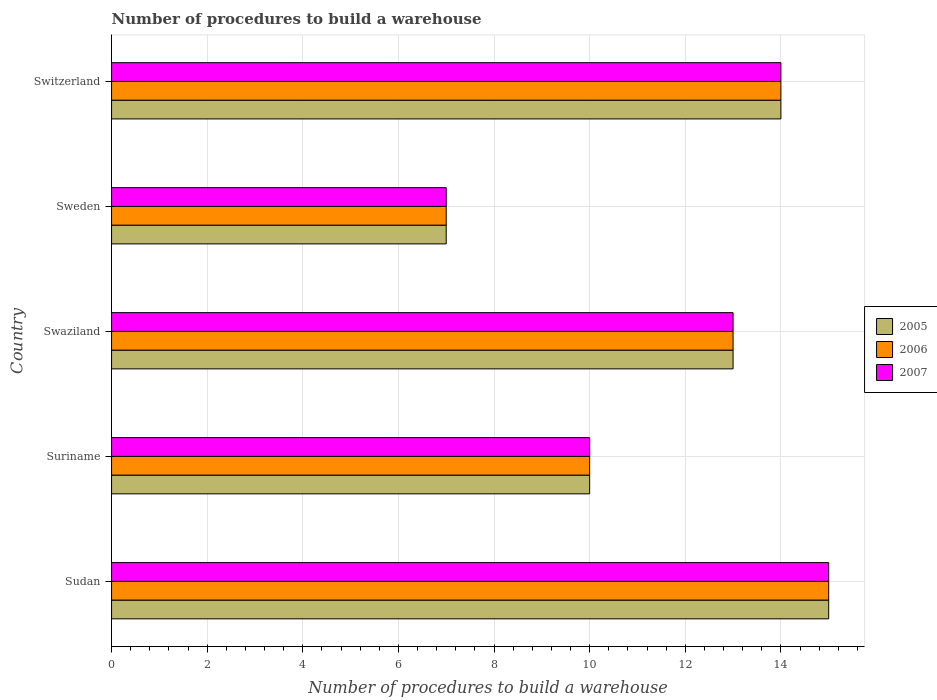How many different coloured bars are there?
Keep it short and to the point. 3. Are the number of bars on each tick of the Y-axis equal?
Offer a very short reply. Yes. How many bars are there on the 1st tick from the top?
Keep it short and to the point. 3. How many bars are there on the 1st tick from the bottom?
Your answer should be compact. 3. What is the label of the 5th group of bars from the top?
Your response must be concise. Sudan. In how many cases, is the number of bars for a given country not equal to the number of legend labels?
Offer a terse response. 0. Across all countries, what is the maximum number of procedures to build a warehouse in in 2005?
Provide a succinct answer. 15. In which country was the number of procedures to build a warehouse in in 2007 maximum?
Offer a very short reply. Sudan. In which country was the number of procedures to build a warehouse in in 2005 minimum?
Provide a short and direct response. Sweden. What is the difference between the number of procedures to build a warehouse in in 2006 in Sudan and the number of procedures to build a warehouse in in 2005 in Swaziland?
Give a very brief answer. 2. What is the difference between the number of procedures to build a warehouse in in 2006 and number of procedures to build a warehouse in in 2005 in Swaziland?
Your response must be concise. 0. What is the ratio of the number of procedures to build a warehouse in in 2007 in Suriname to that in Sweden?
Offer a terse response. 1.43. Is the difference between the number of procedures to build a warehouse in in 2006 in Sweden and Switzerland greater than the difference between the number of procedures to build a warehouse in in 2005 in Sweden and Switzerland?
Provide a short and direct response. No. What is the difference between the highest and the lowest number of procedures to build a warehouse in in 2005?
Offer a very short reply. 8. In how many countries, is the number of procedures to build a warehouse in in 2005 greater than the average number of procedures to build a warehouse in in 2005 taken over all countries?
Offer a terse response. 3. Is the sum of the number of procedures to build a warehouse in in 2005 in Sudan and Suriname greater than the maximum number of procedures to build a warehouse in in 2007 across all countries?
Make the answer very short. Yes. What does the 1st bar from the top in Swaziland represents?
Provide a succinct answer. 2007. What does the 2nd bar from the bottom in Suriname represents?
Your response must be concise. 2006. Are all the bars in the graph horizontal?
Ensure brevity in your answer.  Yes. How many countries are there in the graph?
Provide a succinct answer. 5. Are the values on the major ticks of X-axis written in scientific E-notation?
Provide a succinct answer. No. Does the graph contain grids?
Provide a short and direct response. Yes. How many legend labels are there?
Your answer should be compact. 3. How are the legend labels stacked?
Ensure brevity in your answer.  Vertical. What is the title of the graph?
Offer a terse response. Number of procedures to build a warehouse. Does "1991" appear as one of the legend labels in the graph?
Ensure brevity in your answer.  No. What is the label or title of the X-axis?
Keep it short and to the point. Number of procedures to build a warehouse. What is the label or title of the Y-axis?
Give a very brief answer. Country. What is the Number of procedures to build a warehouse of 2006 in Sudan?
Provide a succinct answer. 15. What is the Number of procedures to build a warehouse of 2007 in Suriname?
Provide a short and direct response. 10. What is the Number of procedures to build a warehouse of 2005 in Swaziland?
Your response must be concise. 13. What is the Number of procedures to build a warehouse in 2006 in Swaziland?
Your answer should be compact. 13. What is the Number of procedures to build a warehouse of 2005 in Sweden?
Make the answer very short. 7. What is the Number of procedures to build a warehouse of 2007 in Sweden?
Offer a terse response. 7. Across all countries, what is the maximum Number of procedures to build a warehouse of 2007?
Provide a short and direct response. 15. Across all countries, what is the minimum Number of procedures to build a warehouse of 2006?
Provide a succinct answer. 7. Across all countries, what is the minimum Number of procedures to build a warehouse in 2007?
Ensure brevity in your answer.  7. What is the total Number of procedures to build a warehouse of 2006 in the graph?
Ensure brevity in your answer.  59. What is the difference between the Number of procedures to build a warehouse in 2005 in Sudan and that in Suriname?
Your response must be concise. 5. What is the difference between the Number of procedures to build a warehouse in 2006 in Sudan and that in Suriname?
Keep it short and to the point. 5. What is the difference between the Number of procedures to build a warehouse in 2005 in Sudan and that in Swaziland?
Make the answer very short. 2. What is the difference between the Number of procedures to build a warehouse of 2006 in Sudan and that in Swaziland?
Make the answer very short. 2. What is the difference between the Number of procedures to build a warehouse of 2005 in Sudan and that in Sweden?
Ensure brevity in your answer.  8. What is the difference between the Number of procedures to build a warehouse in 2007 in Sudan and that in Sweden?
Make the answer very short. 8. What is the difference between the Number of procedures to build a warehouse of 2006 in Sudan and that in Switzerland?
Give a very brief answer. 1. What is the difference between the Number of procedures to build a warehouse in 2007 in Sudan and that in Switzerland?
Offer a terse response. 1. What is the difference between the Number of procedures to build a warehouse in 2005 in Suriname and that in Swaziland?
Your answer should be compact. -3. What is the difference between the Number of procedures to build a warehouse of 2006 in Suriname and that in Swaziland?
Give a very brief answer. -3. What is the difference between the Number of procedures to build a warehouse in 2007 in Suriname and that in Swaziland?
Provide a short and direct response. -3. What is the difference between the Number of procedures to build a warehouse of 2005 in Suriname and that in Sweden?
Your response must be concise. 3. What is the difference between the Number of procedures to build a warehouse of 2007 in Suriname and that in Switzerland?
Your answer should be compact. -4. What is the difference between the Number of procedures to build a warehouse of 2005 in Swaziland and that in Sweden?
Provide a short and direct response. 6. What is the difference between the Number of procedures to build a warehouse of 2005 in Swaziland and that in Switzerland?
Your answer should be compact. -1. What is the difference between the Number of procedures to build a warehouse in 2006 in Swaziland and that in Switzerland?
Make the answer very short. -1. What is the difference between the Number of procedures to build a warehouse in 2005 in Sweden and that in Switzerland?
Your answer should be very brief. -7. What is the difference between the Number of procedures to build a warehouse in 2007 in Sweden and that in Switzerland?
Provide a short and direct response. -7. What is the difference between the Number of procedures to build a warehouse of 2005 in Sudan and the Number of procedures to build a warehouse of 2007 in Suriname?
Your response must be concise. 5. What is the difference between the Number of procedures to build a warehouse in 2005 in Sudan and the Number of procedures to build a warehouse in 2006 in Swaziland?
Provide a short and direct response. 2. What is the difference between the Number of procedures to build a warehouse in 2005 in Sudan and the Number of procedures to build a warehouse in 2007 in Swaziland?
Provide a short and direct response. 2. What is the difference between the Number of procedures to build a warehouse of 2006 in Sudan and the Number of procedures to build a warehouse of 2007 in Swaziland?
Make the answer very short. 2. What is the difference between the Number of procedures to build a warehouse in 2005 in Sudan and the Number of procedures to build a warehouse in 2006 in Sweden?
Give a very brief answer. 8. What is the difference between the Number of procedures to build a warehouse of 2005 in Sudan and the Number of procedures to build a warehouse of 2007 in Sweden?
Give a very brief answer. 8. What is the difference between the Number of procedures to build a warehouse of 2005 in Sudan and the Number of procedures to build a warehouse of 2006 in Switzerland?
Your answer should be compact. 1. What is the difference between the Number of procedures to build a warehouse in 2005 in Sudan and the Number of procedures to build a warehouse in 2007 in Switzerland?
Provide a short and direct response. 1. What is the difference between the Number of procedures to build a warehouse of 2006 in Suriname and the Number of procedures to build a warehouse of 2007 in Switzerland?
Your answer should be very brief. -4. What is the difference between the Number of procedures to build a warehouse of 2005 in Swaziland and the Number of procedures to build a warehouse of 2006 in Sweden?
Make the answer very short. 6. What is the difference between the Number of procedures to build a warehouse of 2005 in Swaziland and the Number of procedures to build a warehouse of 2007 in Sweden?
Keep it short and to the point. 6. What is the difference between the Number of procedures to build a warehouse of 2006 in Swaziland and the Number of procedures to build a warehouse of 2007 in Sweden?
Give a very brief answer. 6. What is the difference between the Number of procedures to build a warehouse of 2005 in Swaziland and the Number of procedures to build a warehouse of 2007 in Switzerland?
Your response must be concise. -1. What is the difference between the Number of procedures to build a warehouse in 2005 in Sweden and the Number of procedures to build a warehouse in 2007 in Switzerland?
Provide a succinct answer. -7. What is the average Number of procedures to build a warehouse in 2005 per country?
Offer a terse response. 11.8. What is the average Number of procedures to build a warehouse in 2006 per country?
Your answer should be compact. 11.8. What is the average Number of procedures to build a warehouse of 2007 per country?
Offer a very short reply. 11.8. What is the difference between the Number of procedures to build a warehouse in 2005 and Number of procedures to build a warehouse in 2006 in Sudan?
Provide a short and direct response. 0. What is the difference between the Number of procedures to build a warehouse in 2005 and Number of procedures to build a warehouse in 2007 in Sudan?
Keep it short and to the point. 0. What is the difference between the Number of procedures to build a warehouse of 2006 and Number of procedures to build a warehouse of 2007 in Suriname?
Ensure brevity in your answer.  0. What is the difference between the Number of procedures to build a warehouse in 2005 and Number of procedures to build a warehouse in 2006 in Swaziland?
Your response must be concise. 0. What is the difference between the Number of procedures to build a warehouse of 2006 and Number of procedures to build a warehouse of 2007 in Sweden?
Your response must be concise. 0. What is the difference between the Number of procedures to build a warehouse in 2005 and Number of procedures to build a warehouse in 2006 in Switzerland?
Your response must be concise. 0. What is the difference between the Number of procedures to build a warehouse of 2006 and Number of procedures to build a warehouse of 2007 in Switzerland?
Ensure brevity in your answer.  0. What is the ratio of the Number of procedures to build a warehouse of 2006 in Sudan to that in Suriname?
Give a very brief answer. 1.5. What is the ratio of the Number of procedures to build a warehouse in 2007 in Sudan to that in Suriname?
Provide a succinct answer. 1.5. What is the ratio of the Number of procedures to build a warehouse of 2005 in Sudan to that in Swaziland?
Provide a short and direct response. 1.15. What is the ratio of the Number of procedures to build a warehouse in 2006 in Sudan to that in Swaziland?
Offer a terse response. 1.15. What is the ratio of the Number of procedures to build a warehouse in 2007 in Sudan to that in Swaziland?
Keep it short and to the point. 1.15. What is the ratio of the Number of procedures to build a warehouse of 2005 in Sudan to that in Sweden?
Your answer should be very brief. 2.14. What is the ratio of the Number of procedures to build a warehouse in 2006 in Sudan to that in Sweden?
Give a very brief answer. 2.14. What is the ratio of the Number of procedures to build a warehouse of 2007 in Sudan to that in Sweden?
Give a very brief answer. 2.14. What is the ratio of the Number of procedures to build a warehouse in 2005 in Sudan to that in Switzerland?
Offer a very short reply. 1.07. What is the ratio of the Number of procedures to build a warehouse of 2006 in Sudan to that in Switzerland?
Your answer should be very brief. 1.07. What is the ratio of the Number of procedures to build a warehouse in 2007 in Sudan to that in Switzerland?
Give a very brief answer. 1.07. What is the ratio of the Number of procedures to build a warehouse of 2005 in Suriname to that in Swaziland?
Offer a very short reply. 0.77. What is the ratio of the Number of procedures to build a warehouse of 2006 in Suriname to that in Swaziland?
Provide a short and direct response. 0.77. What is the ratio of the Number of procedures to build a warehouse in 2007 in Suriname to that in Swaziland?
Your response must be concise. 0.77. What is the ratio of the Number of procedures to build a warehouse of 2005 in Suriname to that in Sweden?
Your answer should be very brief. 1.43. What is the ratio of the Number of procedures to build a warehouse in 2006 in Suriname to that in Sweden?
Provide a short and direct response. 1.43. What is the ratio of the Number of procedures to build a warehouse of 2007 in Suriname to that in Sweden?
Provide a short and direct response. 1.43. What is the ratio of the Number of procedures to build a warehouse in 2005 in Suriname to that in Switzerland?
Provide a succinct answer. 0.71. What is the ratio of the Number of procedures to build a warehouse of 2006 in Suriname to that in Switzerland?
Your answer should be very brief. 0.71. What is the ratio of the Number of procedures to build a warehouse in 2007 in Suriname to that in Switzerland?
Ensure brevity in your answer.  0.71. What is the ratio of the Number of procedures to build a warehouse of 2005 in Swaziland to that in Sweden?
Provide a succinct answer. 1.86. What is the ratio of the Number of procedures to build a warehouse of 2006 in Swaziland to that in Sweden?
Your answer should be very brief. 1.86. What is the ratio of the Number of procedures to build a warehouse in 2007 in Swaziland to that in Sweden?
Your answer should be compact. 1.86. What is the ratio of the Number of procedures to build a warehouse in 2006 in Swaziland to that in Switzerland?
Keep it short and to the point. 0.93. What is the ratio of the Number of procedures to build a warehouse of 2007 in Swaziland to that in Switzerland?
Your answer should be compact. 0.93. What is the difference between the highest and the second highest Number of procedures to build a warehouse in 2005?
Your answer should be very brief. 1. What is the difference between the highest and the lowest Number of procedures to build a warehouse of 2006?
Your answer should be very brief. 8. 